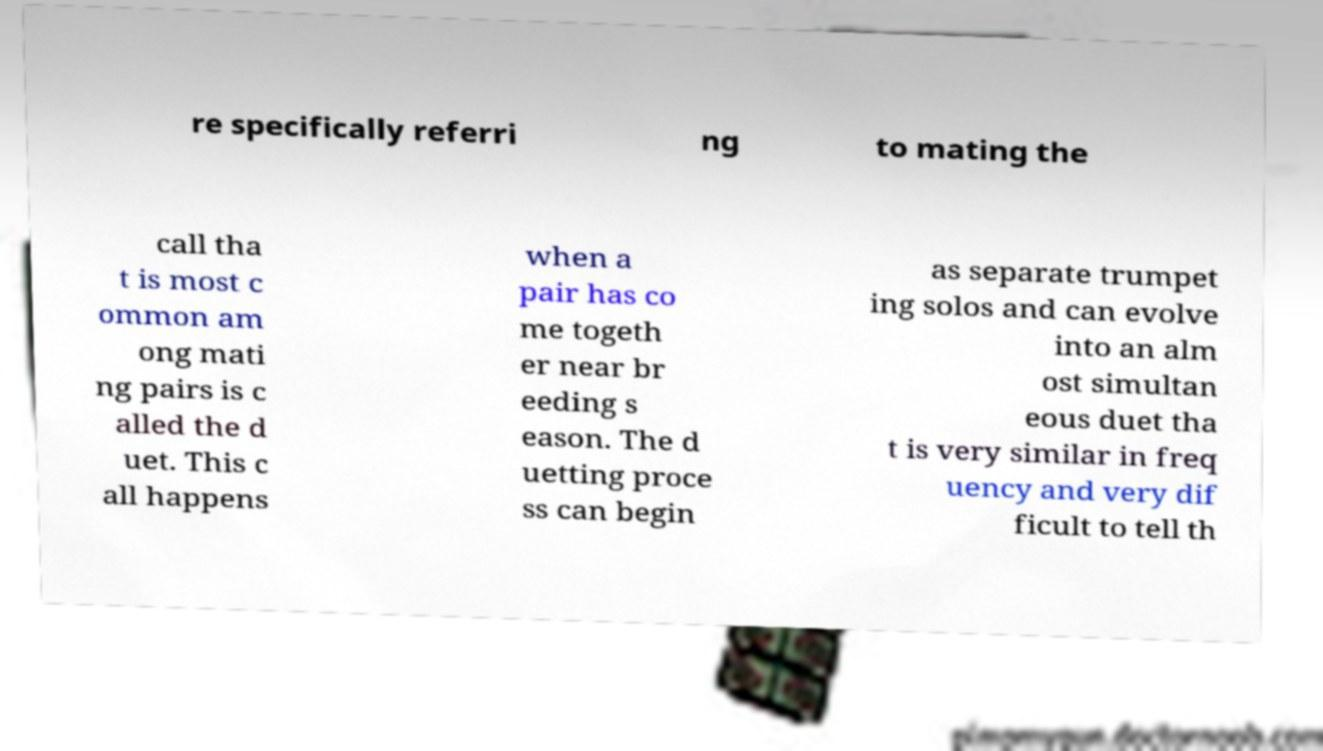Could you assist in decoding the text presented in this image and type it out clearly? re specifically referri ng to mating the call tha t is most c ommon am ong mati ng pairs is c alled the d uet. This c all happens when a pair has co me togeth er near br eeding s eason. The d uetting proce ss can begin as separate trumpet ing solos and can evolve into an alm ost simultan eous duet tha t is very similar in freq uency and very dif ficult to tell th 